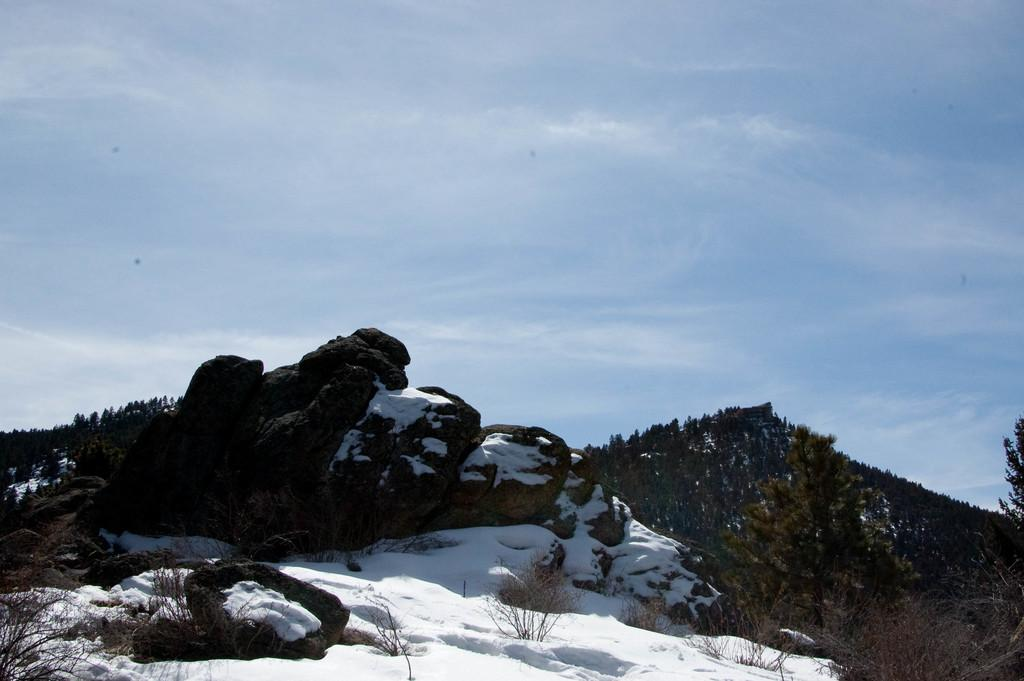What type of natural elements are present in the image? There are stones in the image. What is covering the stones in the image? The stones have snow on them. What type of vegetation can be seen in the image? There are trees on the right side of the image. What is visible in the background of the image? There is a hill in the background of the image. What is on the hill in the image? The hill has trees on it. What is visible at the top of the image? The sky is visible at the top of the image. Can you tell me how many frogs are sitting on the snow-covered stones in the image? There are no frogs present in the image; it features stones covered in snow. What type of vegetable is growing on the hill in the image? There are no vegetables visible in the image; the hill has trees on it. 